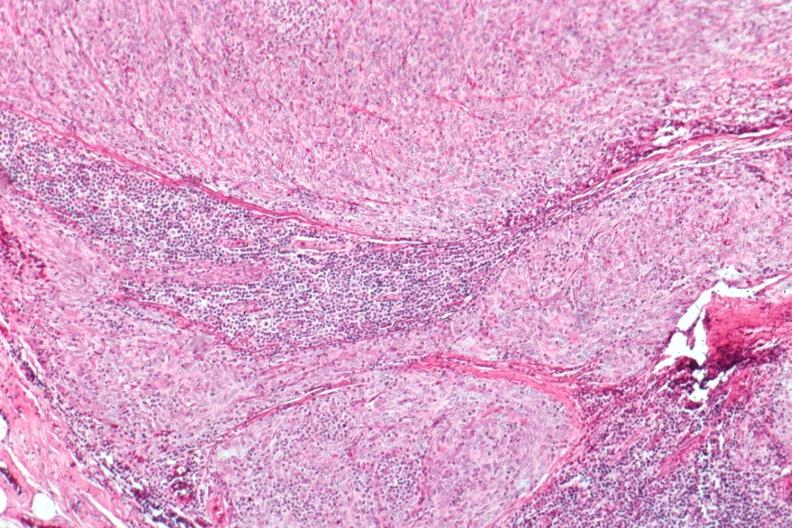s hematologic present?
Answer the question using a single word or phrase. Yes 